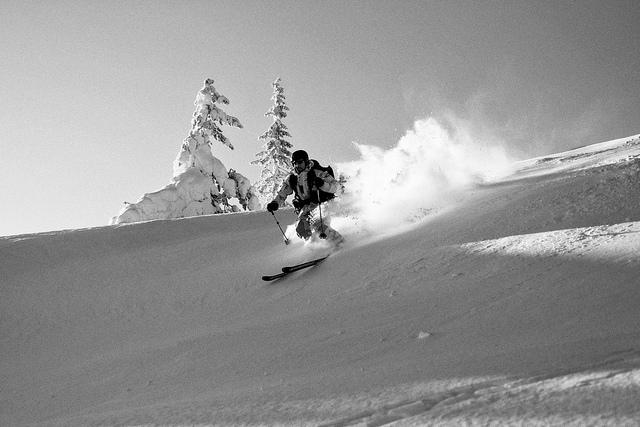Is this person good at skiing?
Keep it brief. Yes. What covers the trees?
Concise answer only. Snow. How many trucks do you see?
Write a very short answer. 0. Where is the surfer?
Answer briefly. Skiing. Where was the photo taken?
Concise answer only. Mountain. Is the guy a good surfer?
Answer briefly. No. Is the picture black or white?
Give a very brief answer. Yes. How many skiers are there?
Keep it brief. 1. What color is the sky?
Write a very short answer. Gray. 